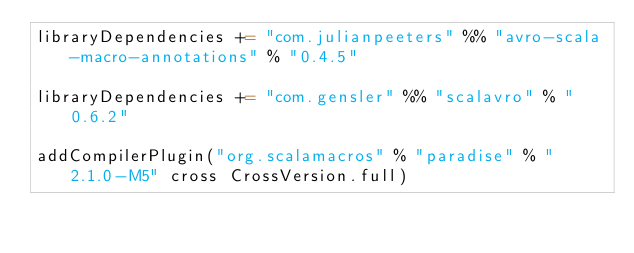Convert code to text. <code><loc_0><loc_0><loc_500><loc_500><_Scala_>libraryDependencies += "com.julianpeeters" %% "avro-scala-macro-annotations" % "0.4.5"

libraryDependencies += "com.gensler" %% "scalavro" % "0.6.2"

addCompilerPlugin("org.scalamacros" % "paradise" % "2.1.0-M5" cross CrossVersion.full)
</code> 